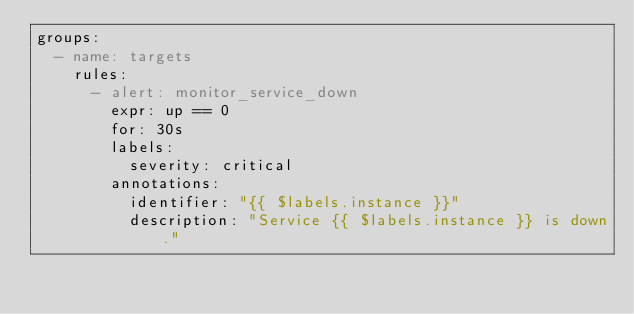<code> <loc_0><loc_0><loc_500><loc_500><_YAML_>groups:
  - name: targets
    rules:
      - alert: monitor_service_down
        expr: up == 0
        for: 30s
        labels:
          severity: critical
        annotations:
          identifier: "{{ $labels.instance }}"
          description: "Service {{ $labels.instance }} is down."
</code> 